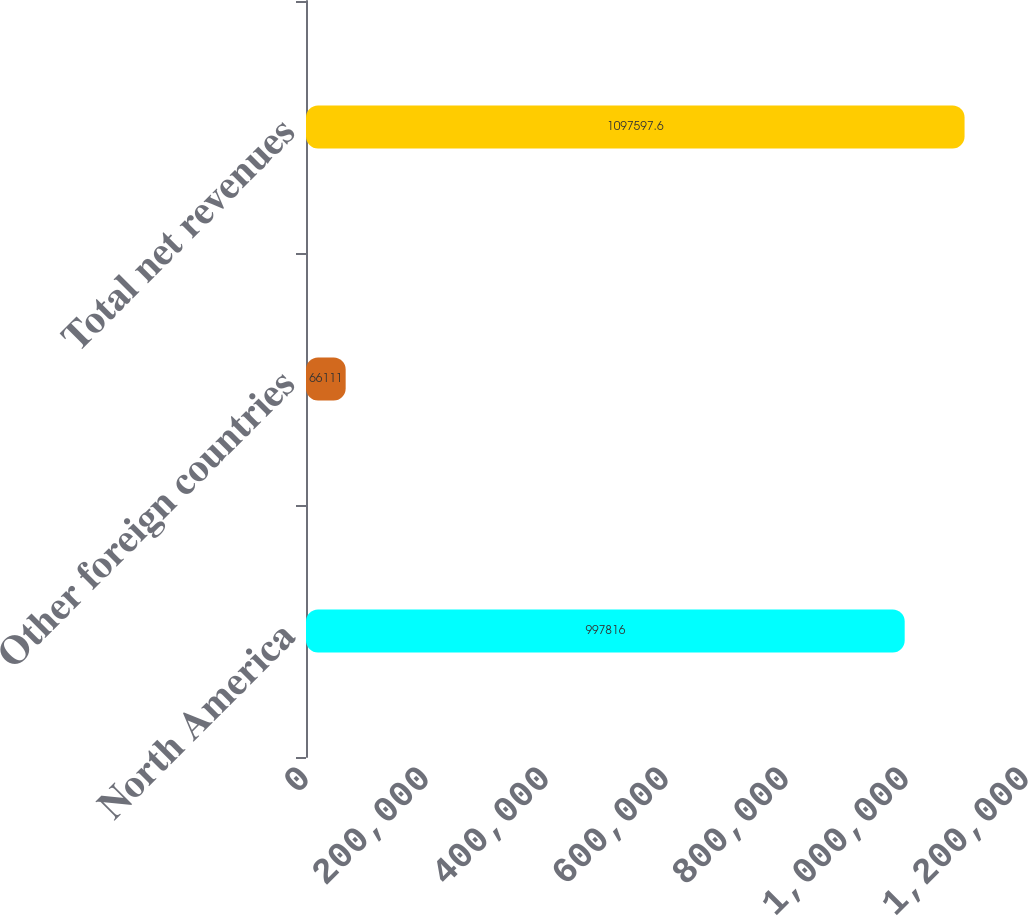<chart> <loc_0><loc_0><loc_500><loc_500><bar_chart><fcel>North America<fcel>Other foreign countries<fcel>Total net revenues<nl><fcel>997816<fcel>66111<fcel>1.0976e+06<nl></chart> 